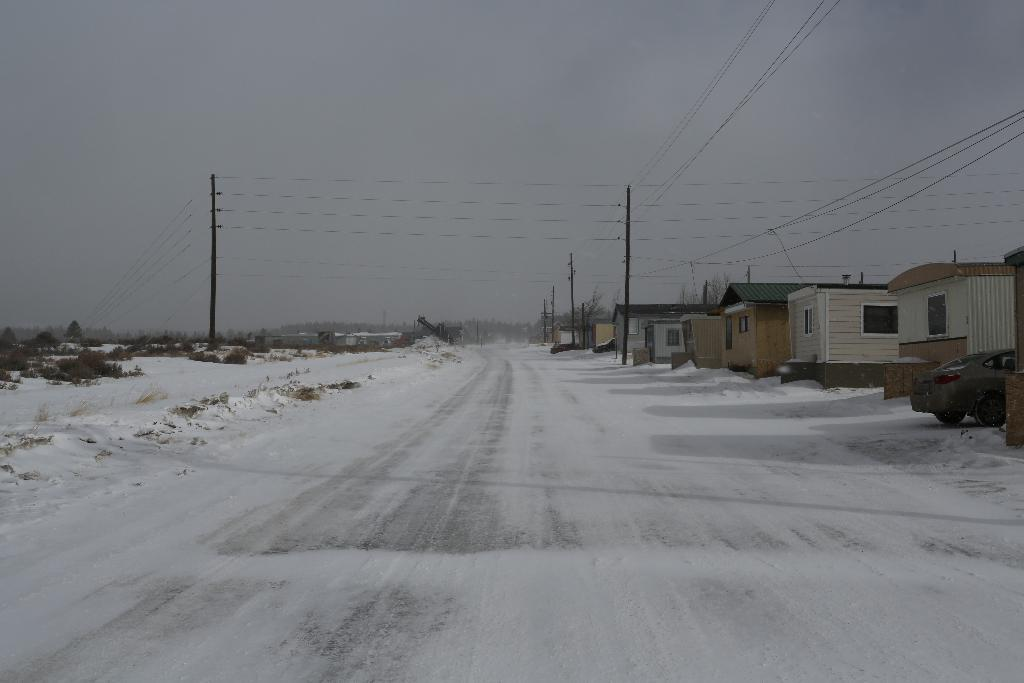What is the condition of the road in the image? The road has snow on it in the image. What can be seen on the road in the image? There is a car on the road in the image. What type of structures are visible in the image? There are houses with windows in the image. What is present above the houses in the image? The sky is visible in the background of the image. What else can be seen in the image besides the road and houses? There are poles, wires, trees, and a car in the image. What type of apparel is the dock wearing in the image? There is no dock or apparel present in the image. What season is depicted in the image? The image does not depict a specific season, but the presence of snow suggests it could be winter. 